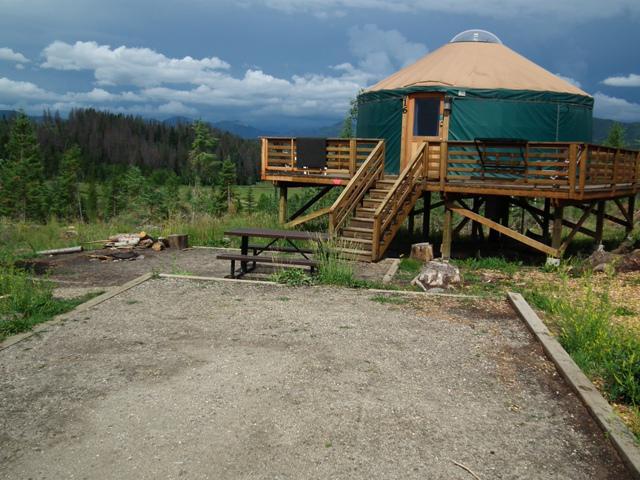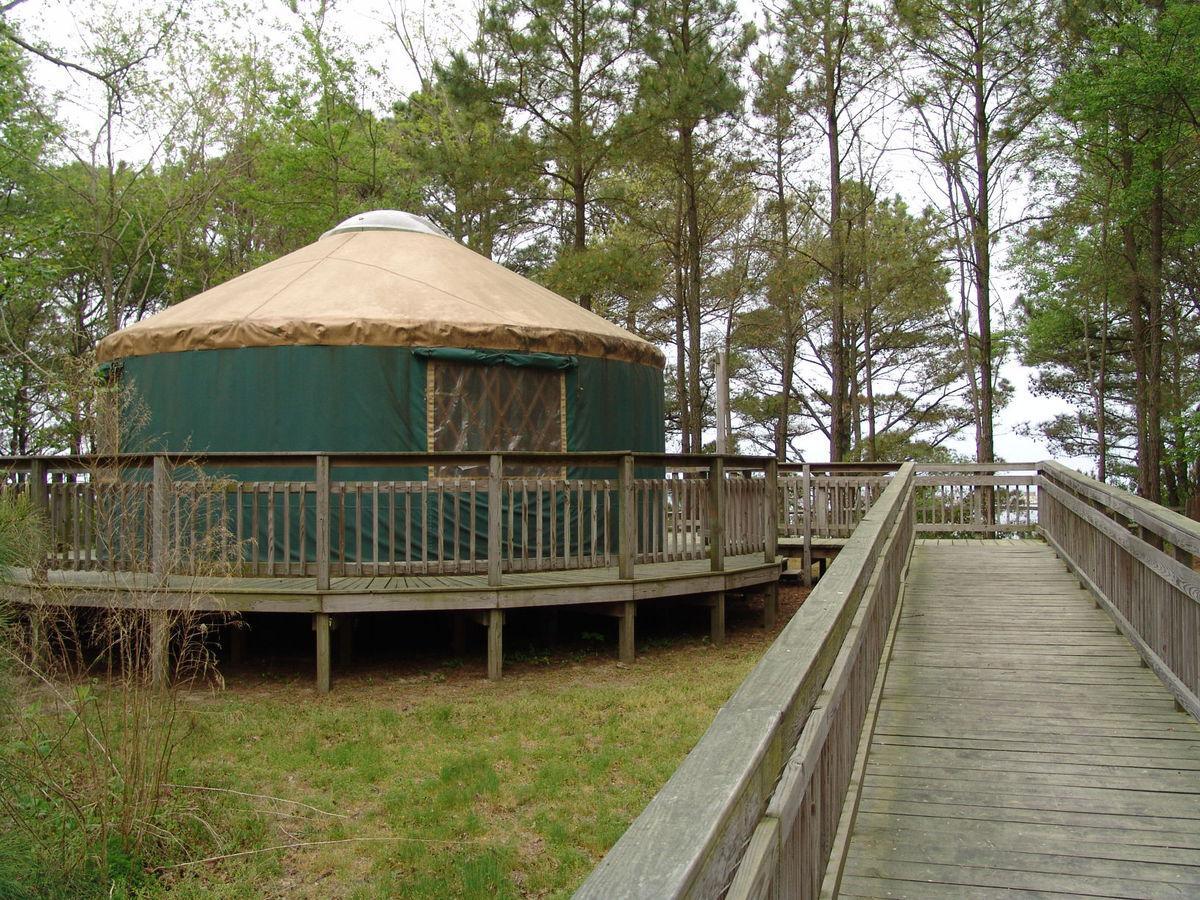The first image is the image on the left, the second image is the image on the right. Considering the images on both sides, is "At least one image contains 3 or more yurts." valid? Answer yes or no. No. The first image is the image on the left, the second image is the image on the right. For the images displayed, is the sentence "the huts are not all white but have color" factually correct? Answer yes or no. Yes. 